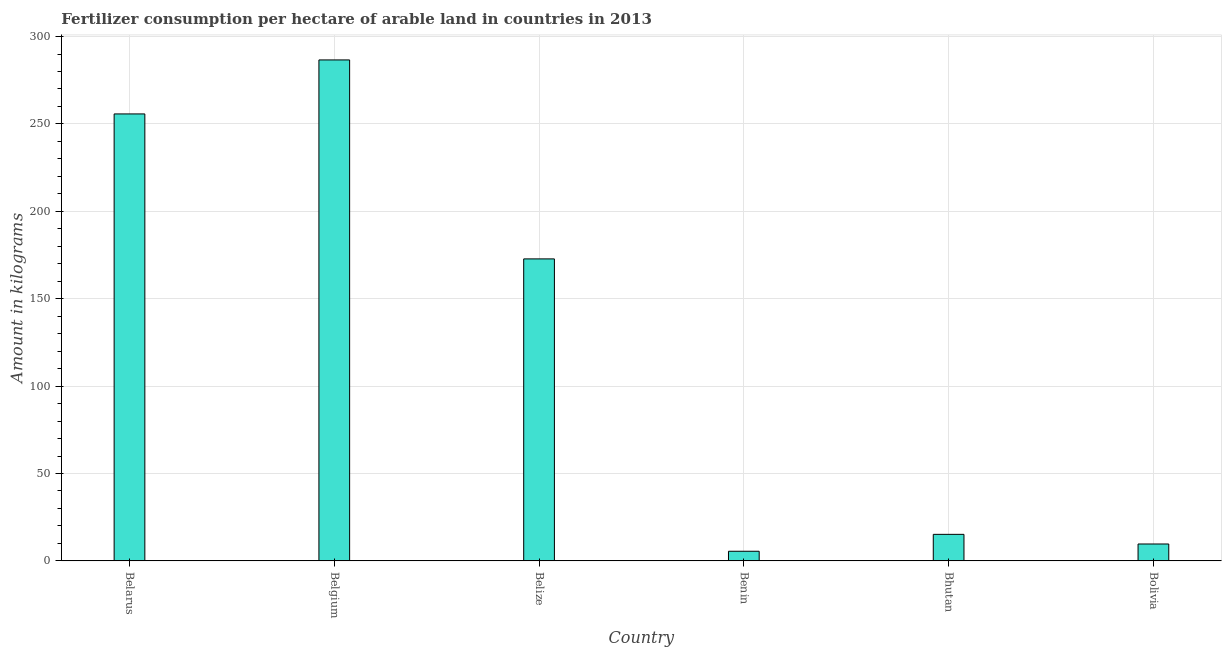What is the title of the graph?
Keep it short and to the point. Fertilizer consumption per hectare of arable land in countries in 2013 . What is the label or title of the X-axis?
Your answer should be very brief. Country. What is the label or title of the Y-axis?
Offer a terse response. Amount in kilograms. What is the amount of fertilizer consumption in Bhutan?
Give a very brief answer. 15.19. Across all countries, what is the maximum amount of fertilizer consumption?
Your response must be concise. 286.61. Across all countries, what is the minimum amount of fertilizer consumption?
Provide a short and direct response. 5.52. In which country was the amount of fertilizer consumption maximum?
Offer a very short reply. Belgium. In which country was the amount of fertilizer consumption minimum?
Ensure brevity in your answer.  Benin. What is the sum of the amount of fertilizer consumption?
Your answer should be very brief. 745.49. What is the difference between the amount of fertilizer consumption in Bhutan and Bolivia?
Provide a short and direct response. 5.51. What is the average amount of fertilizer consumption per country?
Offer a very short reply. 124.25. What is the median amount of fertilizer consumption?
Your answer should be compact. 93.99. In how many countries, is the amount of fertilizer consumption greater than 280 kg?
Offer a terse response. 1. What is the ratio of the amount of fertilizer consumption in Bhutan to that in Bolivia?
Ensure brevity in your answer.  1.57. Is the difference between the amount of fertilizer consumption in Belarus and Bhutan greater than the difference between any two countries?
Provide a succinct answer. No. What is the difference between the highest and the second highest amount of fertilizer consumption?
Keep it short and to the point. 30.9. What is the difference between the highest and the lowest amount of fertilizer consumption?
Offer a terse response. 281.1. How many bars are there?
Make the answer very short. 6. Are all the bars in the graph horizontal?
Keep it short and to the point. No. What is the difference between two consecutive major ticks on the Y-axis?
Offer a very short reply. 50. Are the values on the major ticks of Y-axis written in scientific E-notation?
Offer a terse response. No. What is the Amount in kilograms of Belarus?
Provide a succinct answer. 255.71. What is the Amount in kilograms in Belgium?
Your response must be concise. 286.61. What is the Amount in kilograms in Belize?
Make the answer very short. 172.78. What is the Amount in kilograms of Benin?
Offer a terse response. 5.52. What is the Amount in kilograms in Bhutan?
Your response must be concise. 15.19. What is the Amount in kilograms in Bolivia?
Provide a succinct answer. 9.68. What is the difference between the Amount in kilograms in Belarus and Belgium?
Offer a very short reply. -30.9. What is the difference between the Amount in kilograms in Belarus and Belize?
Give a very brief answer. 82.93. What is the difference between the Amount in kilograms in Belarus and Benin?
Provide a short and direct response. 250.2. What is the difference between the Amount in kilograms in Belarus and Bhutan?
Ensure brevity in your answer.  240.53. What is the difference between the Amount in kilograms in Belarus and Bolivia?
Ensure brevity in your answer.  246.04. What is the difference between the Amount in kilograms in Belgium and Belize?
Ensure brevity in your answer.  113.83. What is the difference between the Amount in kilograms in Belgium and Benin?
Your response must be concise. 281.1. What is the difference between the Amount in kilograms in Belgium and Bhutan?
Give a very brief answer. 271.42. What is the difference between the Amount in kilograms in Belgium and Bolivia?
Ensure brevity in your answer.  276.94. What is the difference between the Amount in kilograms in Belize and Benin?
Keep it short and to the point. 167.26. What is the difference between the Amount in kilograms in Belize and Bhutan?
Provide a short and direct response. 157.59. What is the difference between the Amount in kilograms in Belize and Bolivia?
Your response must be concise. 163.11. What is the difference between the Amount in kilograms in Benin and Bhutan?
Your answer should be very brief. -9.67. What is the difference between the Amount in kilograms in Benin and Bolivia?
Your answer should be compact. -4.16. What is the difference between the Amount in kilograms in Bhutan and Bolivia?
Ensure brevity in your answer.  5.51. What is the ratio of the Amount in kilograms in Belarus to that in Belgium?
Your answer should be compact. 0.89. What is the ratio of the Amount in kilograms in Belarus to that in Belize?
Provide a short and direct response. 1.48. What is the ratio of the Amount in kilograms in Belarus to that in Benin?
Provide a succinct answer. 46.33. What is the ratio of the Amount in kilograms in Belarus to that in Bhutan?
Your response must be concise. 16.84. What is the ratio of the Amount in kilograms in Belarus to that in Bolivia?
Offer a very short reply. 26.43. What is the ratio of the Amount in kilograms in Belgium to that in Belize?
Your answer should be very brief. 1.66. What is the ratio of the Amount in kilograms in Belgium to that in Benin?
Your answer should be compact. 51.93. What is the ratio of the Amount in kilograms in Belgium to that in Bhutan?
Your response must be concise. 18.87. What is the ratio of the Amount in kilograms in Belgium to that in Bolivia?
Your answer should be compact. 29.62. What is the ratio of the Amount in kilograms in Belize to that in Benin?
Your response must be concise. 31.31. What is the ratio of the Amount in kilograms in Belize to that in Bhutan?
Your response must be concise. 11.38. What is the ratio of the Amount in kilograms in Belize to that in Bolivia?
Your response must be concise. 17.86. What is the ratio of the Amount in kilograms in Benin to that in Bhutan?
Give a very brief answer. 0.36. What is the ratio of the Amount in kilograms in Benin to that in Bolivia?
Give a very brief answer. 0.57. What is the ratio of the Amount in kilograms in Bhutan to that in Bolivia?
Offer a very short reply. 1.57. 